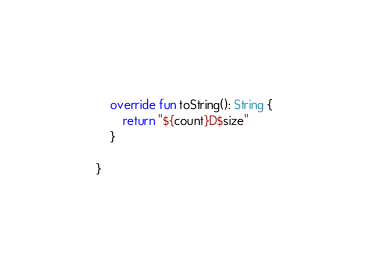Convert code to text. <code><loc_0><loc_0><loc_500><loc_500><_Kotlin_>	override fun toString(): String {
		return "${count}D$size"
	}

}</code> 